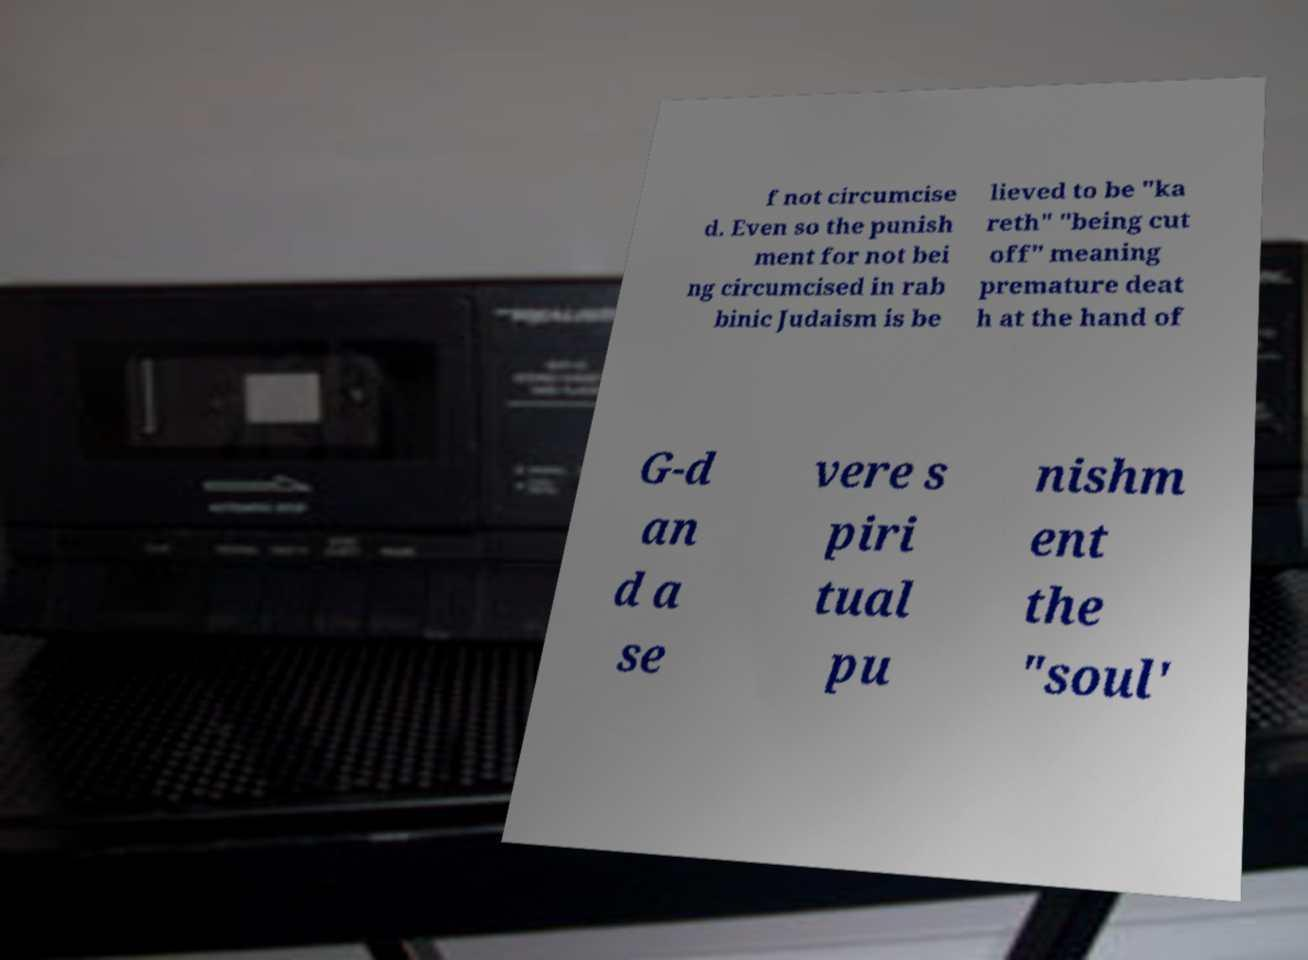Could you extract and type out the text from this image? f not circumcise d. Even so the punish ment for not bei ng circumcised in rab binic Judaism is be lieved to be "ka reth" "being cut off" meaning premature deat h at the hand of G-d an d a se vere s piri tual pu nishm ent the "soul' 